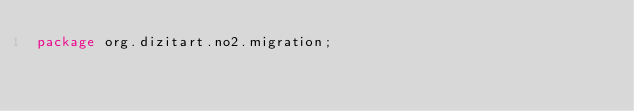<code> <loc_0><loc_0><loc_500><loc_500><_Java_>package org.dizitart.no2.migration;
</code> 